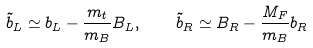<formula> <loc_0><loc_0><loc_500><loc_500>\tilde { b } _ { L } \simeq b _ { L } - \frac { m _ { t } } { m _ { B } } B _ { L } , \quad \tilde { b } _ { R } \simeq B _ { R } - \frac { M _ { F } } { m _ { B } } b _ { R }</formula> 